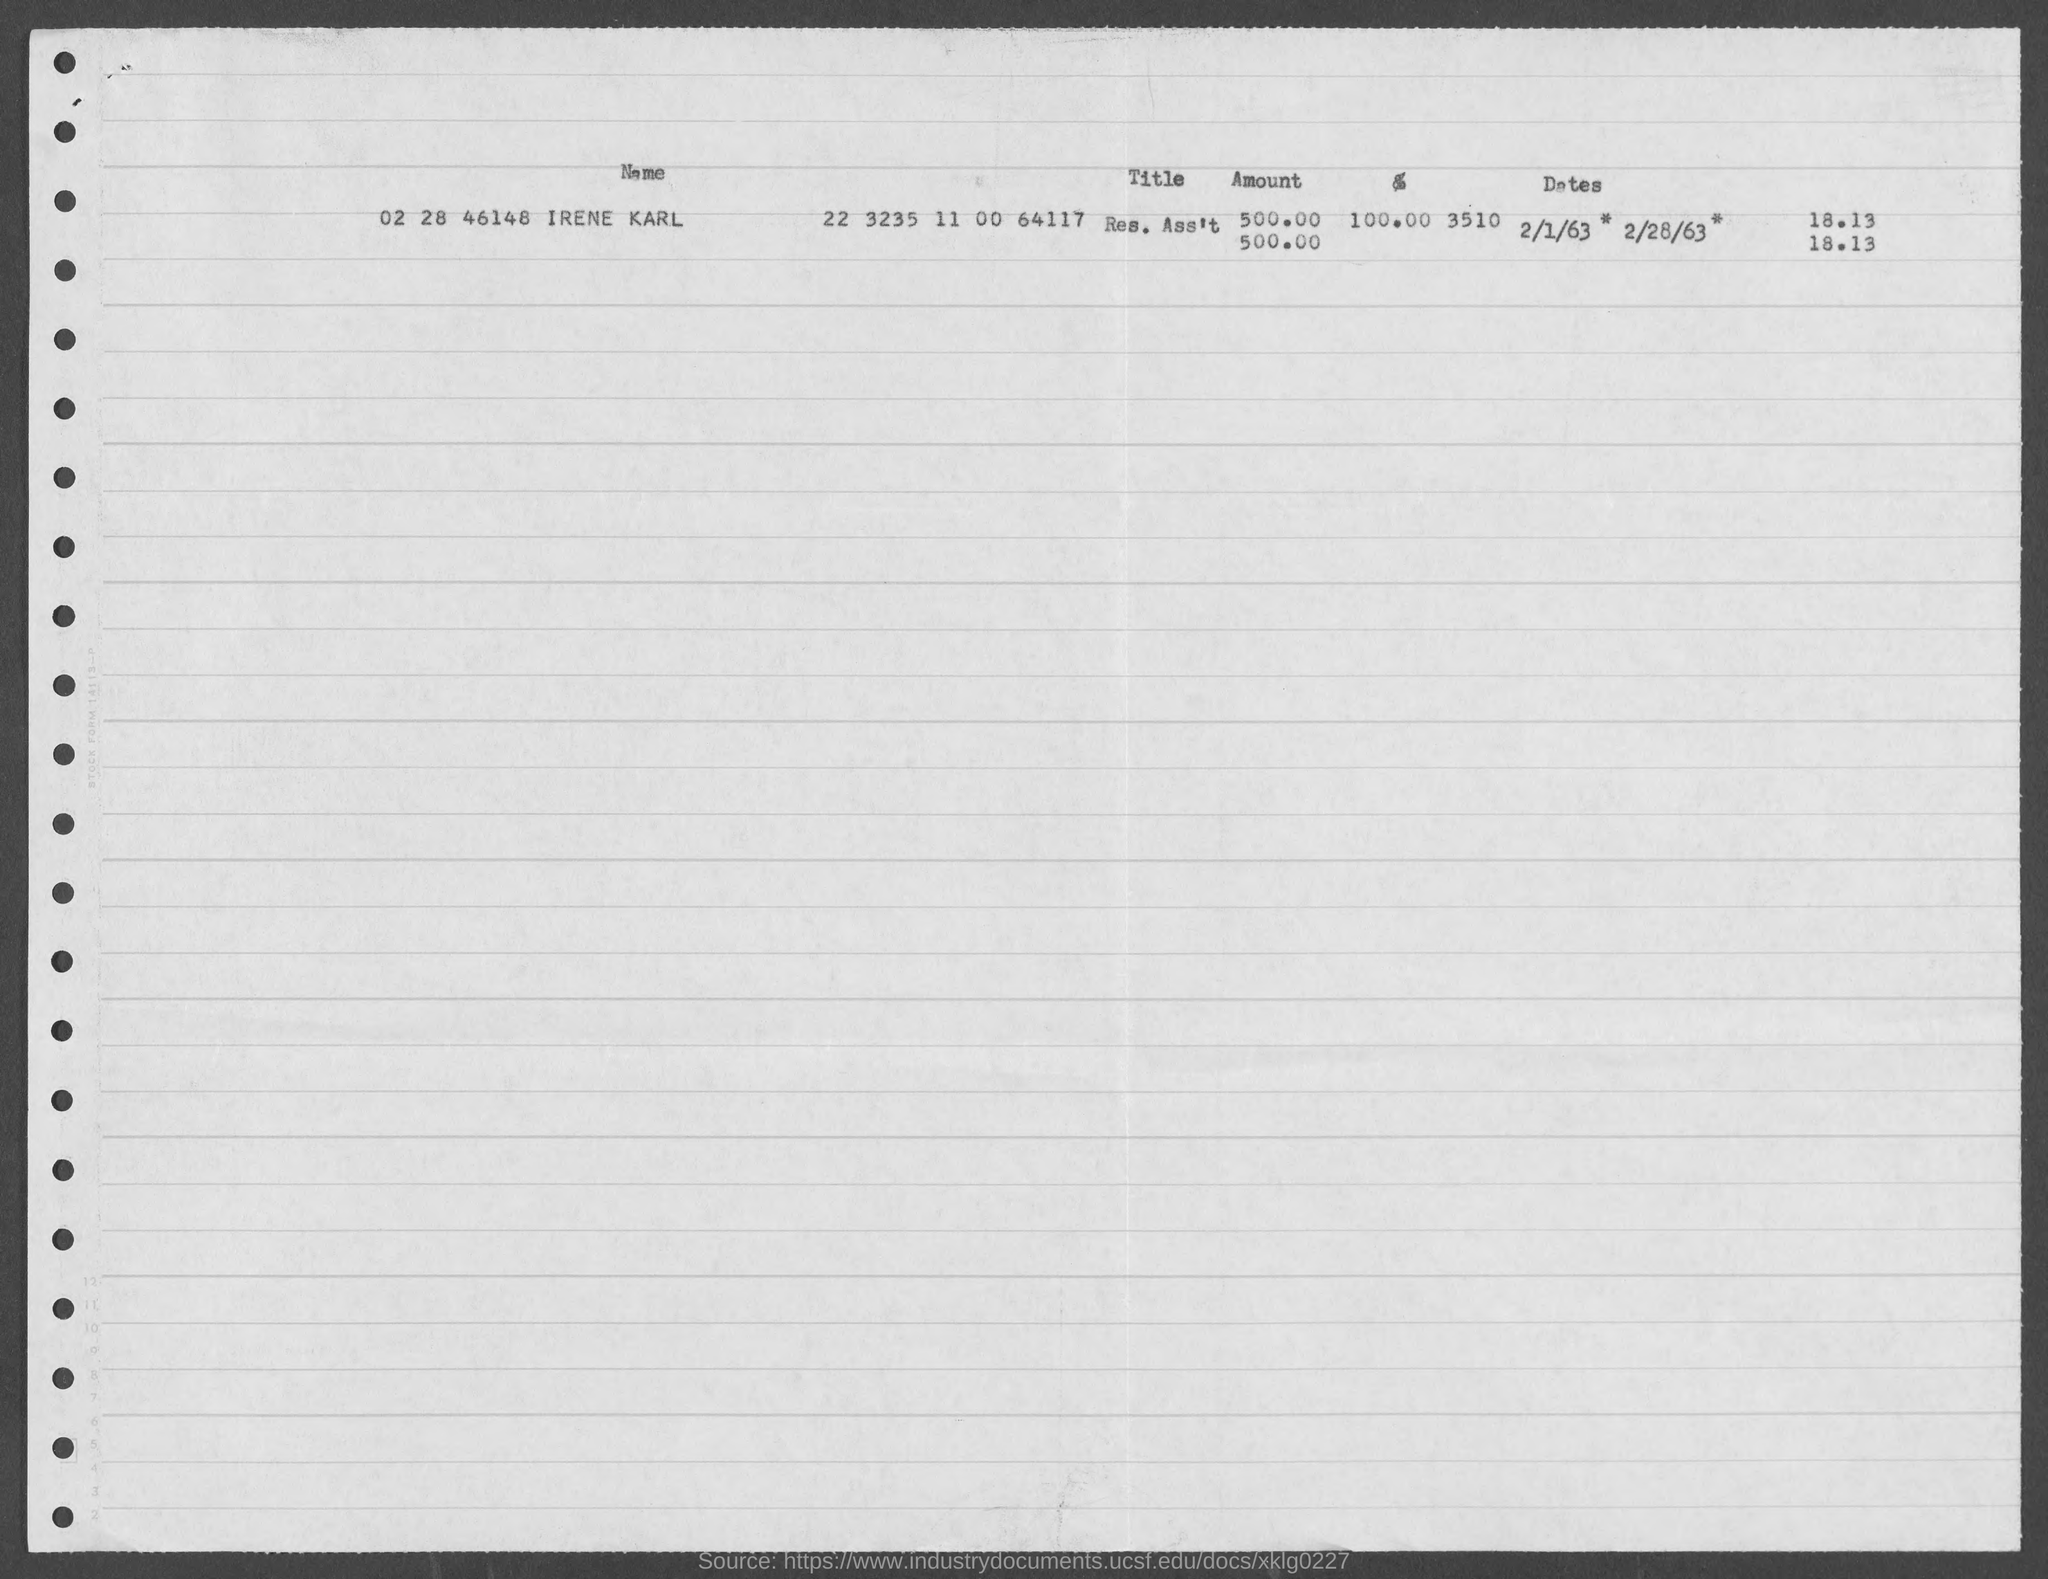What is the name of the person?
Give a very brief answer. Irene Karl. What is the title?
Give a very brief answer. Res. Ass't. What is the amount?
Make the answer very short. 500.00. 